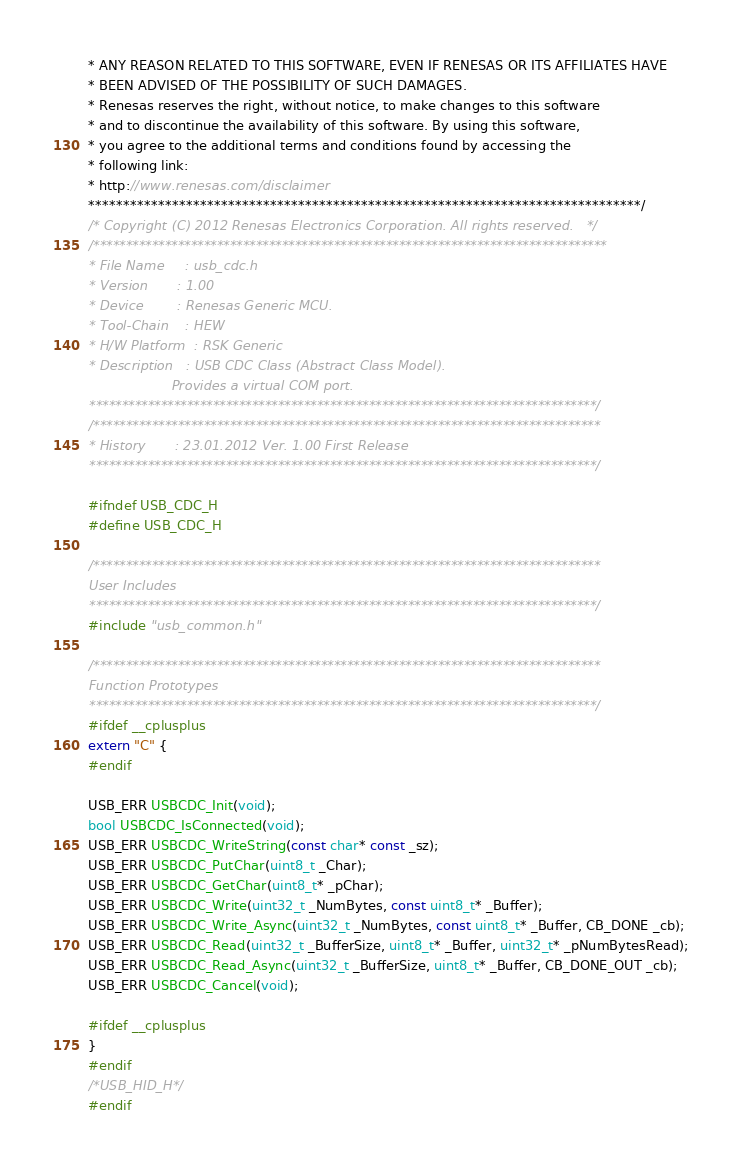Convert code to text. <code><loc_0><loc_0><loc_500><loc_500><_C_>* ANY REASON RELATED TO THIS SOFTWARE, EVEN IF RENESAS OR ITS AFFILIATES HAVE
* BEEN ADVISED OF THE POSSIBILITY OF SUCH DAMAGES.
* Renesas reserves the right, without notice, to make changes to this software
* and to discontinue the availability of this software. By using this software,
* you agree to the additional terms and conditions found by accessing the
* following link:
* http://www.renesas.com/disclaimer
*******************************************************************************/
/* Copyright (C) 2012 Renesas Electronics Corporation. All rights reserved.   */
/*******************************************************************************
* File Name     : usb_cdc.h
* Version       : 1.00
* Device        : Renesas Generic MCU.
* Tool-Chain    : HEW
* H/W Platform  : RSK Generic
* Description   : USB CDC Class (Abstract Class Model).
                    Provides a virtual COM port.
******************************************************************************/
/******************************************************************************
* History       : 23.01.2012 Ver. 1.00 First Release
******************************************************************************/

#ifndef USB_CDC_H
#define USB_CDC_H

/******************************************************************************
User Includes
******************************************************************************/
#include "usb_common.h"

/******************************************************************************
Function Prototypes
******************************************************************************/
#ifdef __cplusplus
extern "C" {
#endif

USB_ERR USBCDC_Init(void);
bool USBCDC_IsConnected(void);
USB_ERR USBCDC_WriteString(const char* const _sz);
USB_ERR USBCDC_PutChar(uint8_t _Char);
USB_ERR USBCDC_GetChar(uint8_t* _pChar);
USB_ERR USBCDC_Write(uint32_t _NumBytes, const uint8_t* _Buffer);
USB_ERR USBCDC_Write_Async(uint32_t _NumBytes, const uint8_t* _Buffer, CB_DONE _cb);
USB_ERR USBCDC_Read(uint32_t _BufferSize, uint8_t* _Buffer, uint32_t* _pNumBytesRead);
USB_ERR USBCDC_Read_Async(uint32_t _BufferSize, uint8_t* _Buffer, CB_DONE_OUT _cb);
USB_ERR USBCDC_Cancel(void);

#ifdef __cplusplus
}
#endif
/*USB_HID_H*/
#endif
</code> 